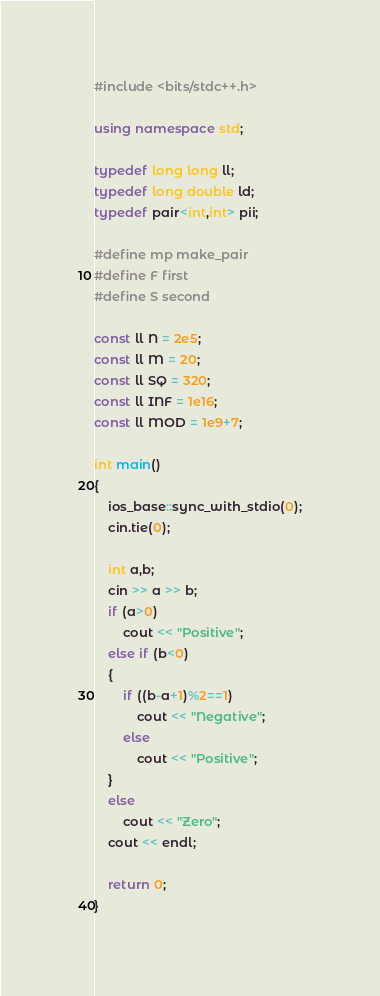<code> <loc_0><loc_0><loc_500><loc_500><_C++_>#include <bits/stdc++.h>

using namespace std;

typedef long long ll;
typedef long double ld;
typedef pair<int,int> pii; 

#define mp make_pair
#define F first
#define S second

const ll N = 2e5;
const ll M = 20;
const ll SQ = 320;
const ll INF = 1e16;
const ll MOD = 1e9+7;

int main()
{
	ios_base::sync_with_stdio(0);
	cin.tie(0);
	
	int a,b;
	cin >> a >> b;
	if (a>0)
		cout << "Positive";
	else if (b<0)
	{
		if ((b-a+1)%2==1)
			cout << "Negative";
		else
			cout << "Positive";
	}
	else
		cout << "Zero";
	cout << endl;

	return 0;
}
</code> 